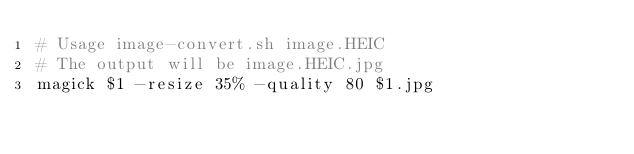<code> <loc_0><loc_0><loc_500><loc_500><_Bash_># Usage image-convert.sh image.HEIC
# The output will be image.HEIC.jpg
magick $1 -resize 35% -quality 80 $1.jpg
</code> 